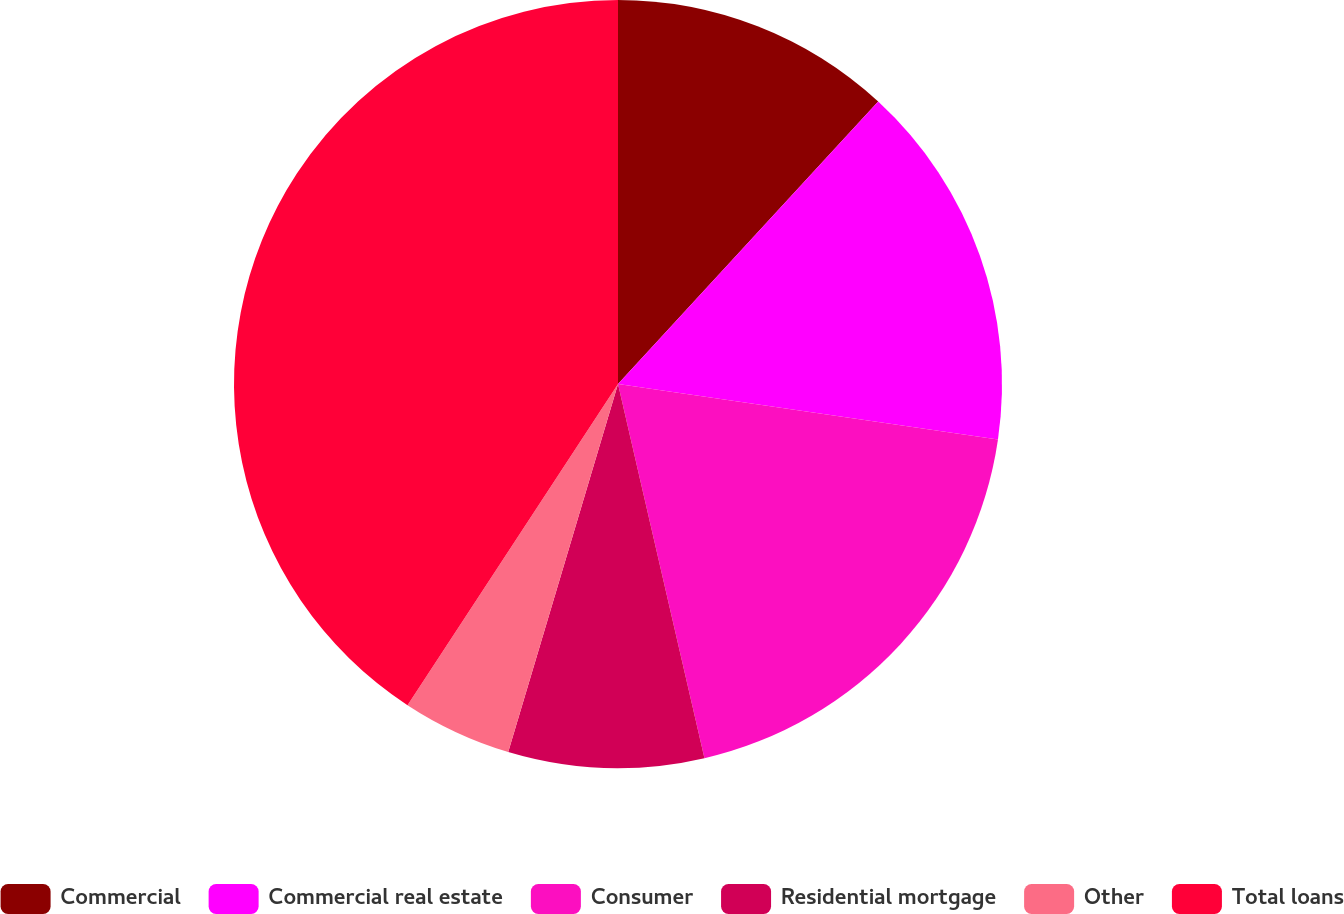Convert chart. <chart><loc_0><loc_0><loc_500><loc_500><pie_chart><fcel>Commercial<fcel>Commercial real estate<fcel>Consumer<fcel>Residential mortgage<fcel>Other<fcel>Total loans<nl><fcel>11.85%<fcel>15.46%<fcel>19.08%<fcel>8.23%<fcel>4.62%<fcel>40.77%<nl></chart> 